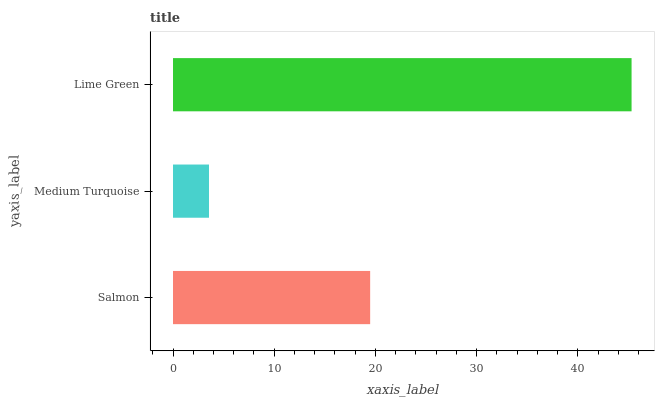Is Medium Turquoise the minimum?
Answer yes or no. Yes. Is Lime Green the maximum?
Answer yes or no. Yes. Is Lime Green the minimum?
Answer yes or no. No. Is Medium Turquoise the maximum?
Answer yes or no. No. Is Lime Green greater than Medium Turquoise?
Answer yes or no. Yes. Is Medium Turquoise less than Lime Green?
Answer yes or no. Yes. Is Medium Turquoise greater than Lime Green?
Answer yes or no. No. Is Lime Green less than Medium Turquoise?
Answer yes or no. No. Is Salmon the high median?
Answer yes or no. Yes. Is Salmon the low median?
Answer yes or no. Yes. Is Lime Green the high median?
Answer yes or no. No. Is Lime Green the low median?
Answer yes or no. No. 